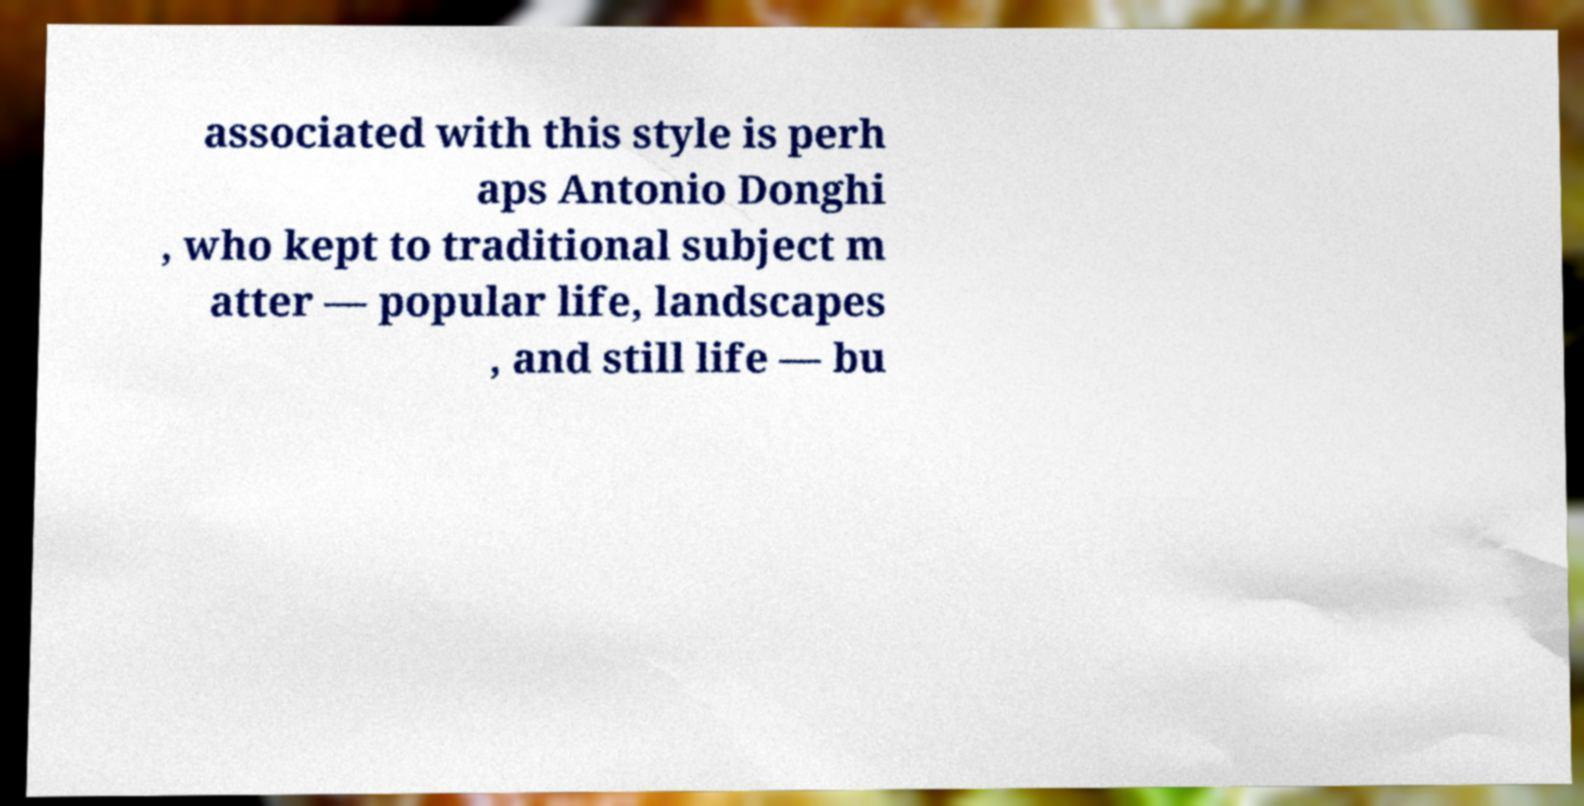What messages or text are displayed in this image? I need them in a readable, typed format. associated with this style is perh aps Antonio Donghi , who kept to traditional subject m atter — popular life, landscapes , and still life — bu 